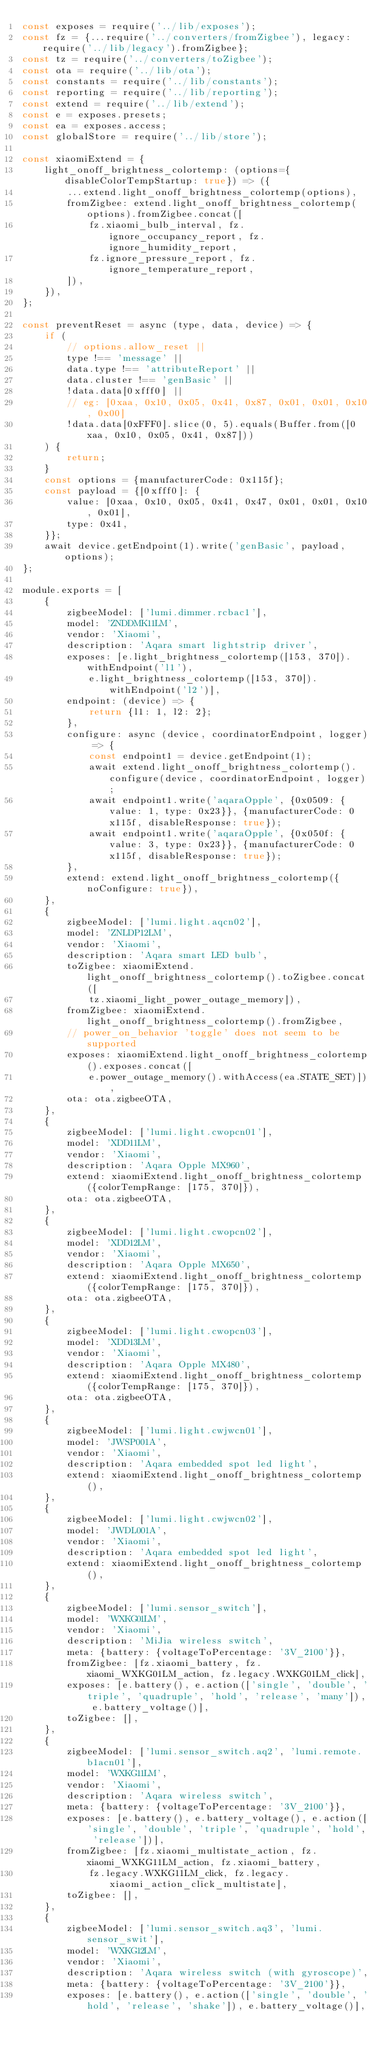<code> <loc_0><loc_0><loc_500><loc_500><_JavaScript_>const exposes = require('../lib/exposes');
const fz = {...require('../converters/fromZigbee'), legacy: require('../lib/legacy').fromZigbee};
const tz = require('../converters/toZigbee');
const ota = require('../lib/ota');
const constants = require('../lib/constants');
const reporting = require('../lib/reporting');
const extend = require('../lib/extend');
const e = exposes.presets;
const ea = exposes.access;
const globalStore = require('../lib/store');

const xiaomiExtend = {
    light_onoff_brightness_colortemp: (options={disableColorTempStartup: true}) => ({
        ...extend.light_onoff_brightness_colortemp(options),
        fromZigbee: extend.light_onoff_brightness_colortemp(options).fromZigbee.concat([
            fz.xiaomi_bulb_interval, fz.ignore_occupancy_report, fz.ignore_humidity_report,
            fz.ignore_pressure_report, fz.ignore_temperature_report,
        ]),
    }),
};

const preventReset = async (type, data, device) => {
    if (
        // options.allow_reset ||
        type !== 'message' ||
        data.type !== 'attributeReport' ||
        data.cluster !== 'genBasic' ||
        !data.data[0xfff0] ||
        // eg: [0xaa, 0x10, 0x05, 0x41, 0x87, 0x01, 0x01, 0x10, 0x00]
        !data.data[0xFFF0].slice(0, 5).equals(Buffer.from([0xaa, 0x10, 0x05, 0x41, 0x87]))
    ) {
        return;
    }
    const options = {manufacturerCode: 0x115f};
    const payload = {[0xfff0]: {
        value: [0xaa, 0x10, 0x05, 0x41, 0x47, 0x01, 0x01, 0x10, 0x01],
        type: 0x41,
    }};
    await device.getEndpoint(1).write('genBasic', payload, options);
};

module.exports = [
    {
        zigbeeModel: ['lumi.dimmer.rcbac1'],
        model: 'ZNDDMK11LM',
        vendor: 'Xiaomi',
        description: 'Aqara smart lightstrip driver',
        exposes: [e.light_brightness_colortemp([153, 370]).withEndpoint('l1'),
            e.light_brightness_colortemp([153, 370]).withEndpoint('l2')],
        endpoint: (device) => {
            return {l1: 1, l2: 2};
        },
        configure: async (device, coordinatorEndpoint, logger) => {
            const endpoint1 = device.getEndpoint(1);
            await extend.light_onoff_brightness_colortemp().configure(device, coordinatorEndpoint, logger);
            await endpoint1.write('aqaraOpple', {0x0509: {value: 1, type: 0x23}}, {manufacturerCode: 0x115f, disableResponse: true});
            await endpoint1.write('aqaraOpple', {0x050f: {value: 3, type: 0x23}}, {manufacturerCode: 0x115f, disableResponse: true});
        },
        extend: extend.light_onoff_brightness_colortemp({noConfigure: true}),
    },
    {
        zigbeeModel: ['lumi.light.aqcn02'],
        model: 'ZNLDP12LM',
        vendor: 'Xiaomi',
        description: 'Aqara smart LED bulb',
        toZigbee: xiaomiExtend.light_onoff_brightness_colortemp().toZigbee.concat([
            tz.xiaomi_light_power_outage_memory]),
        fromZigbee: xiaomiExtend.light_onoff_brightness_colortemp().fromZigbee,
        // power_on_behavior 'toggle' does not seem to be supported
        exposes: xiaomiExtend.light_onoff_brightness_colortemp().exposes.concat([
            e.power_outage_memory().withAccess(ea.STATE_SET)]),
        ota: ota.zigbeeOTA,
    },
    {
        zigbeeModel: ['lumi.light.cwopcn01'],
        model: 'XDD11LM',
        vendor: 'Xiaomi',
        description: 'Aqara Opple MX960',
        extend: xiaomiExtend.light_onoff_brightness_colortemp({colorTempRange: [175, 370]}),
        ota: ota.zigbeeOTA,
    },
    {
        zigbeeModel: ['lumi.light.cwopcn02'],
        model: 'XDD12LM',
        vendor: 'Xiaomi',
        description: 'Aqara Opple MX650',
        extend: xiaomiExtend.light_onoff_brightness_colortemp({colorTempRange: [175, 370]}),
        ota: ota.zigbeeOTA,
    },
    {
        zigbeeModel: ['lumi.light.cwopcn03'],
        model: 'XDD13LM',
        vendor: 'Xiaomi',
        description: 'Aqara Opple MX480',
        extend: xiaomiExtend.light_onoff_brightness_colortemp({colorTempRange: [175, 370]}),
        ota: ota.zigbeeOTA,
    },
    {
        zigbeeModel: ['lumi.light.cwjwcn01'],
        model: 'JWSP001A',
        vendor: 'Xiaomi',
        description: 'Aqara embedded spot led light',
        extend: xiaomiExtend.light_onoff_brightness_colortemp(),
    },
    {
        zigbeeModel: ['lumi.light.cwjwcn02'],
        model: 'JWDL001A',
        vendor: 'Xiaomi',
        description: 'Aqara embedded spot led light',
        extend: xiaomiExtend.light_onoff_brightness_colortemp(),
    },
    {
        zigbeeModel: ['lumi.sensor_switch'],
        model: 'WXKG01LM',
        vendor: 'Xiaomi',
        description: 'MiJia wireless switch',
        meta: {battery: {voltageToPercentage: '3V_2100'}},
        fromZigbee: [fz.xiaomi_battery, fz.xiaomi_WXKG01LM_action, fz.legacy.WXKG01LM_click],
        exposes: [e.battery(), e.action(['single', 'double', 'triple', 'quadruple', 'hold', 'release', 'many']), e.battery_voltage()],
        toZigbee: [],
    },
    {
        zigbeeModel: ['lumi.sensor_switch.aq2', 'lumi.remote.b1acn01'],
        model: 'WXKG11LM',
        vendor: 'Xiaomi',
        description: 'Aqara wireless switch',
        meta: {battery: {voltageToPercentage: '3V_2100'}},
        exposes: [e.battery(), e.battery_voltage(), e.action(['single', 'double', 'triple', 'quadruple', 'hold', 'release'])],
        fromZigbee: [fz.xiaomi_multistate_action, fz.xiaomi_WXKG11LM_action, fz.xiaomi_battery,
            fz.legacy.WXKG11LM_click, fz.legacy.xiaomi_action_click_multistate],
        toZigbee: [],
    },
    {
        zigbeeModel: ['lumi.sensor_switch.aq3', 'lumi.sensor_swit'],
        model: 'WXKG12LM',
        vendor: 'Xiaomi',
        description: 'Aqara wireless switch (with gyroscope)',
        meta: {battery: {voltageToPercentage: '3V_2100'}},
        exposes: [e.battery(), e.action(['single', 'double', 'hold', 'release', 'shake']), e.battery_voltage()],</code> 